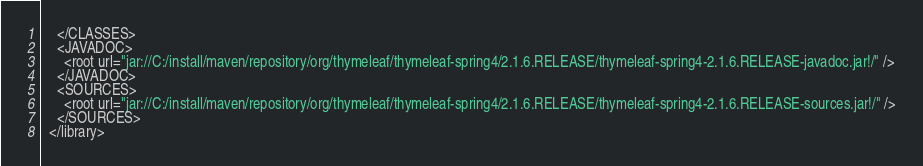<code> <loc_0><loc_0><loc_500><loc_500><_XML_>    </CLASSES>
    <JAVADOC>
      <root url="jar://C:/install/maven/repository/org/thymeleaf/thymeleaf-spring4/2.1.6.RELEASE/thymeleaf-spring4-2.1.6.RELEASE-javadoc.jar!/" />
    </JAVADOC>
    <SOURCES>
      <root url="jar://C:/install/maven/repository/org/thymeleaf/thymeleaf-spring4/2.1.6.RELEASE/thymeleaf-spring4-2.1.6.RELEASE-sources.jar!/" />
    </SOURCES>
  </library></code> 